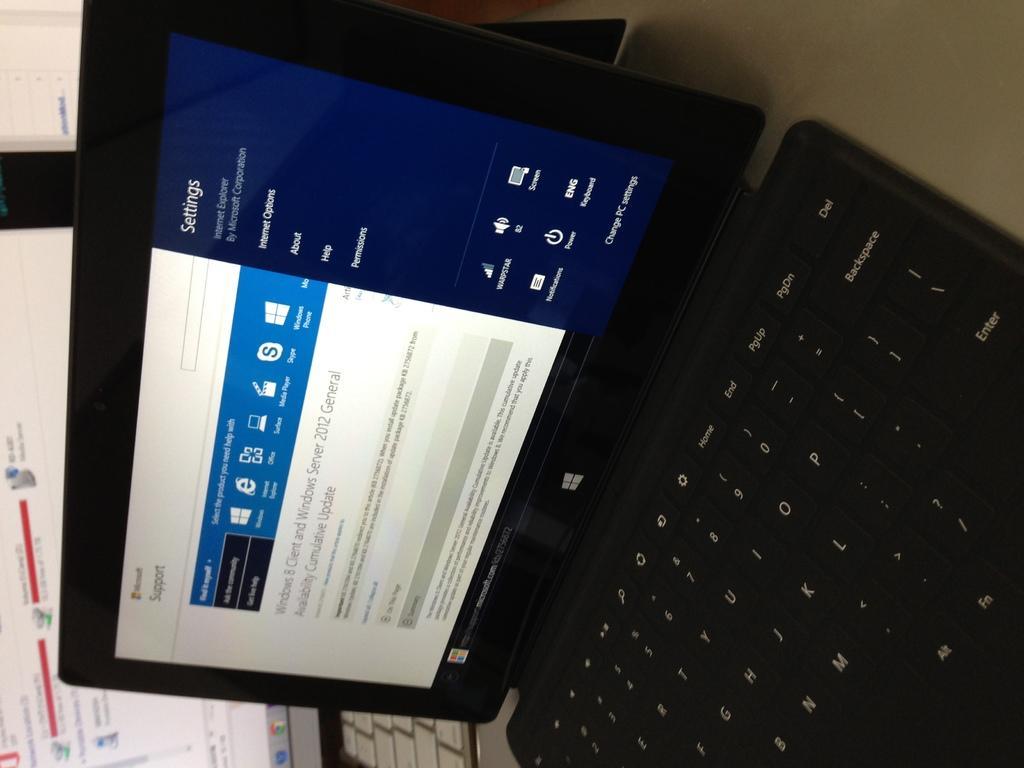Could you give a brief overview of what you see in this image? In this image we can see few laptops. We can see some text and few logos on the laptop screens. 